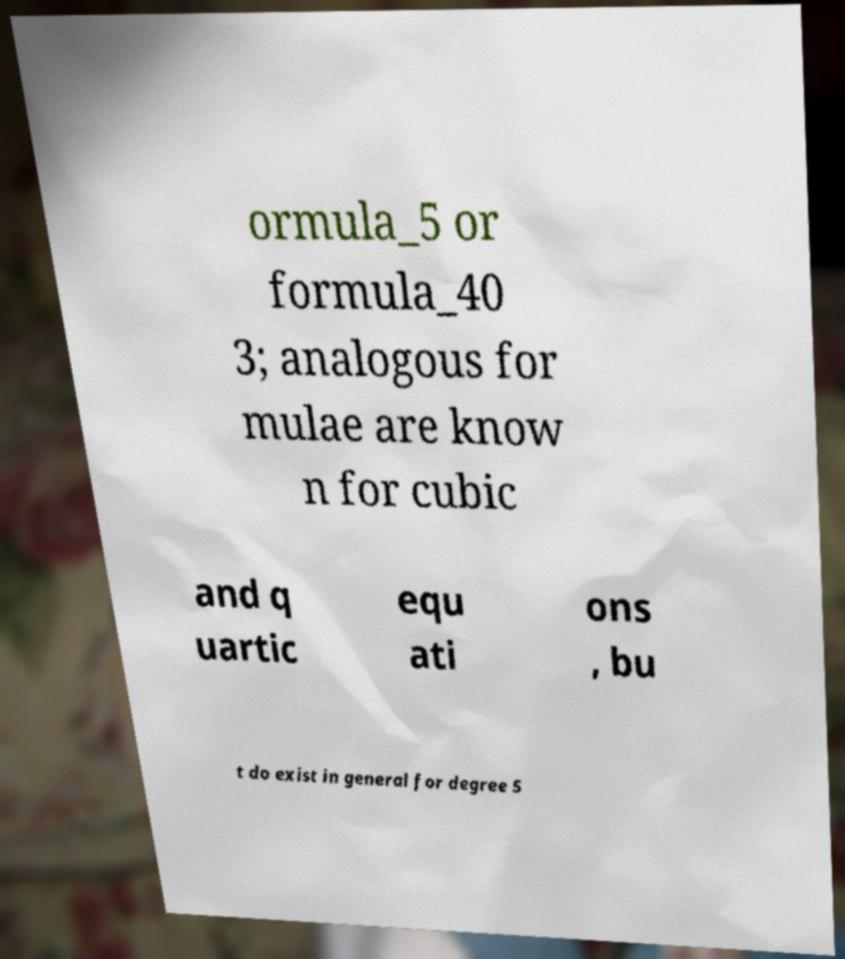What messages or text are displayed in this image? I need them in a readable, typed format. ormula_5 or formula_40 3; analogous for mulae are know n for cubic and q uartic equ ati ons , bu t do exist in general for degree 5 